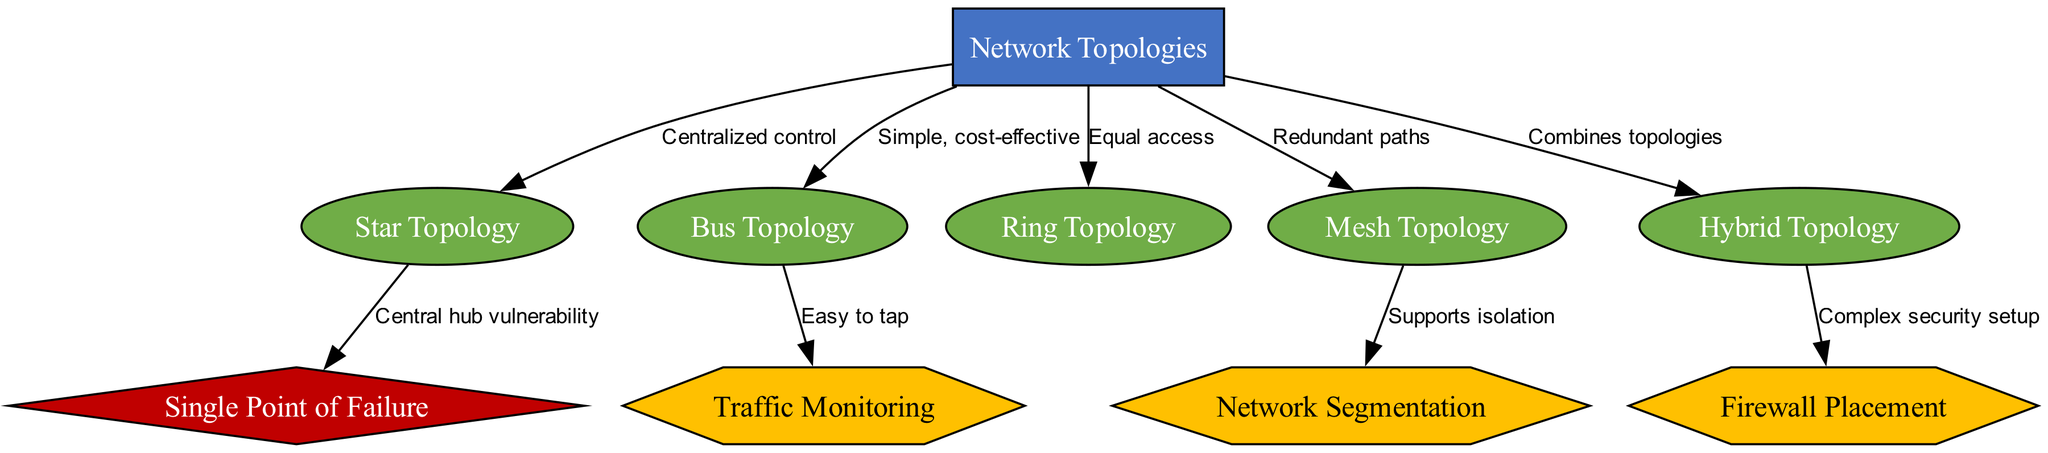What is the central node of the diagram? The central node in the diagram is labeled "Network Topologies." This is evident as it has no incoming edges, indicating it serves as the main subject that connects to all other nodes.
Answer: Network Topologies How many subtopics are presented in the diagram? There are five subtopic nodes represented in the diagram: "Star Topology," "Bus Topology," "Ring Topology," "Mesh Topology," and "Hybrid Topology." Counting these nodes gives a total of five subtopics.
Answer: 5 Which topology has a security concern related to a central hub's vulnerability? The "Star Topology" is connected to the security concern labeled "Central hub vulnerability." This direct connection indicates that the Star Topology has this particular security concern.
Answer: Star Topology What security measure is associated with "Mesh Topology"? "Mesh Topology" is linked to the security measure "Network Segmentation." The direct connection shows that mesh topology supports the concept of network segmentation for enhanced security.
Answer: Network Segmentation Which topology combines multiple topologies? The "Hybrid Topology" is identified in the diagram as combining various topologies. The label attributed to this edge directly indicates its composite nature.
Answer: Hybrid Topology What is the relationship between "Bus Topology" and "Traffic Monitoring"? "Bus Topology" is associated with the security measure labeled "Easy to tap." This suggests that it is particularly susceptible to interception, leading to the importance of traffic monitoring.
Answer: Easy to tap What is a major factor affecting security in a "Ring Topology"? The diagram shows that "Ring Topology" leads to the node labeled "Equal access." This equal access implies that lack of differentiation among nodes can be a security factor to consider.
Answer: Equal access Which topology supports isolation? The "Mesh Topology" is connected to the security measure labeled "Supports isolation." The diagram clearly indicates that this topology contributes to network isolation.
Answer: Supports isolation What node is connected to the "Complex security setup" security measure? The "Hybrid Topology" is directly linked to the "Complex security setup." This shows that implementing a hybrid topology can create complexities in security arrangements.
Answer: Hybrid Topology 